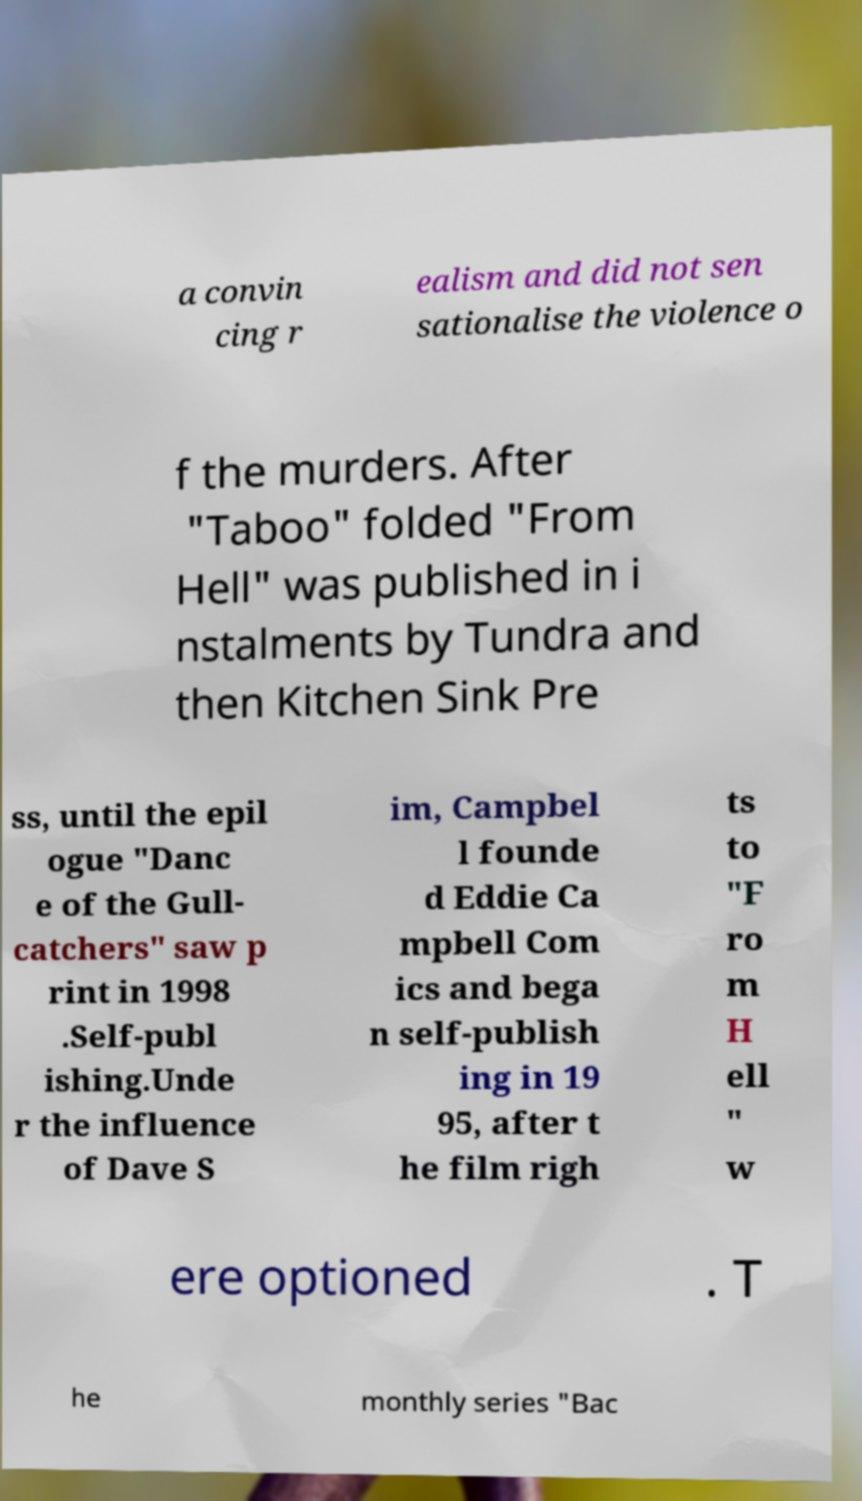Please identify and transcribe the text found in this image. a convin cing r ealism and did not sen sationalise the violence o f the murders. After "Taboo" folded "From Hell" was published in i nstalments by Tundra and then Kitchen Sink Pre ss, until the epil ogue "Danc e of the Gull- catchers" saw p rint in 1998 .Self-publ ishing.Unde r the influence of Dave S im, Campbel l founde d Eddie Ca mpbell Com ics and bega n self-publish ing in 19 95, after t he film righ ts to "F ro m H ell " w ere optioned . T he monthly series "Bac 